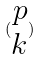<formula> <loc_0><loc_0><loc_500><loc_500>( \begin{matrix} p \\ k \end{matrix} )</formula> 